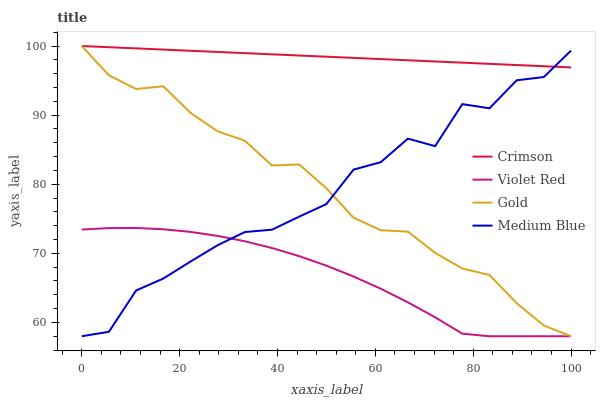Does Violet Red have the minimum area under the curve?
Answer yes or no. Yes. Does Crimson have the maximum area under the curve?
Answer yes or no. Yes. Does Medium Blue have the minimum area under the curve?
Answer yes or no. No. Does Medium Blue have the maximum area under the curve?
Answer yes or no. No. Is Crimson the smoothest?
Answer yes or no. Yes. Is Medium Blue the roughest?
Answer yes or no. Yes. Is Violet Red the smoothest?
Answer yes or no. No. Is Violet Red the roughest?
Answer yes or no. No. Does Violet Red have the lowest value?
Answer yes or no. Yes. Does Gold have the highest value?
Answer yes or no. Yes. Does Medium Blue have the highest value?
Answer yes or no. No. Is Violet Red less than Crimson?
Answer yes or no. Yes. Is Crimson greater than Violet Red?
Answer yes or no. Yes. Does Gold intersect Crimson?
Answer yes or no. Yes. Is Gold less than Crimson?
Answer yes or no. No. Is Gold greater than Crimson?
Answer yes or no. No. Does Violet Red intersect Crimson?
Answer yes or no. No. 